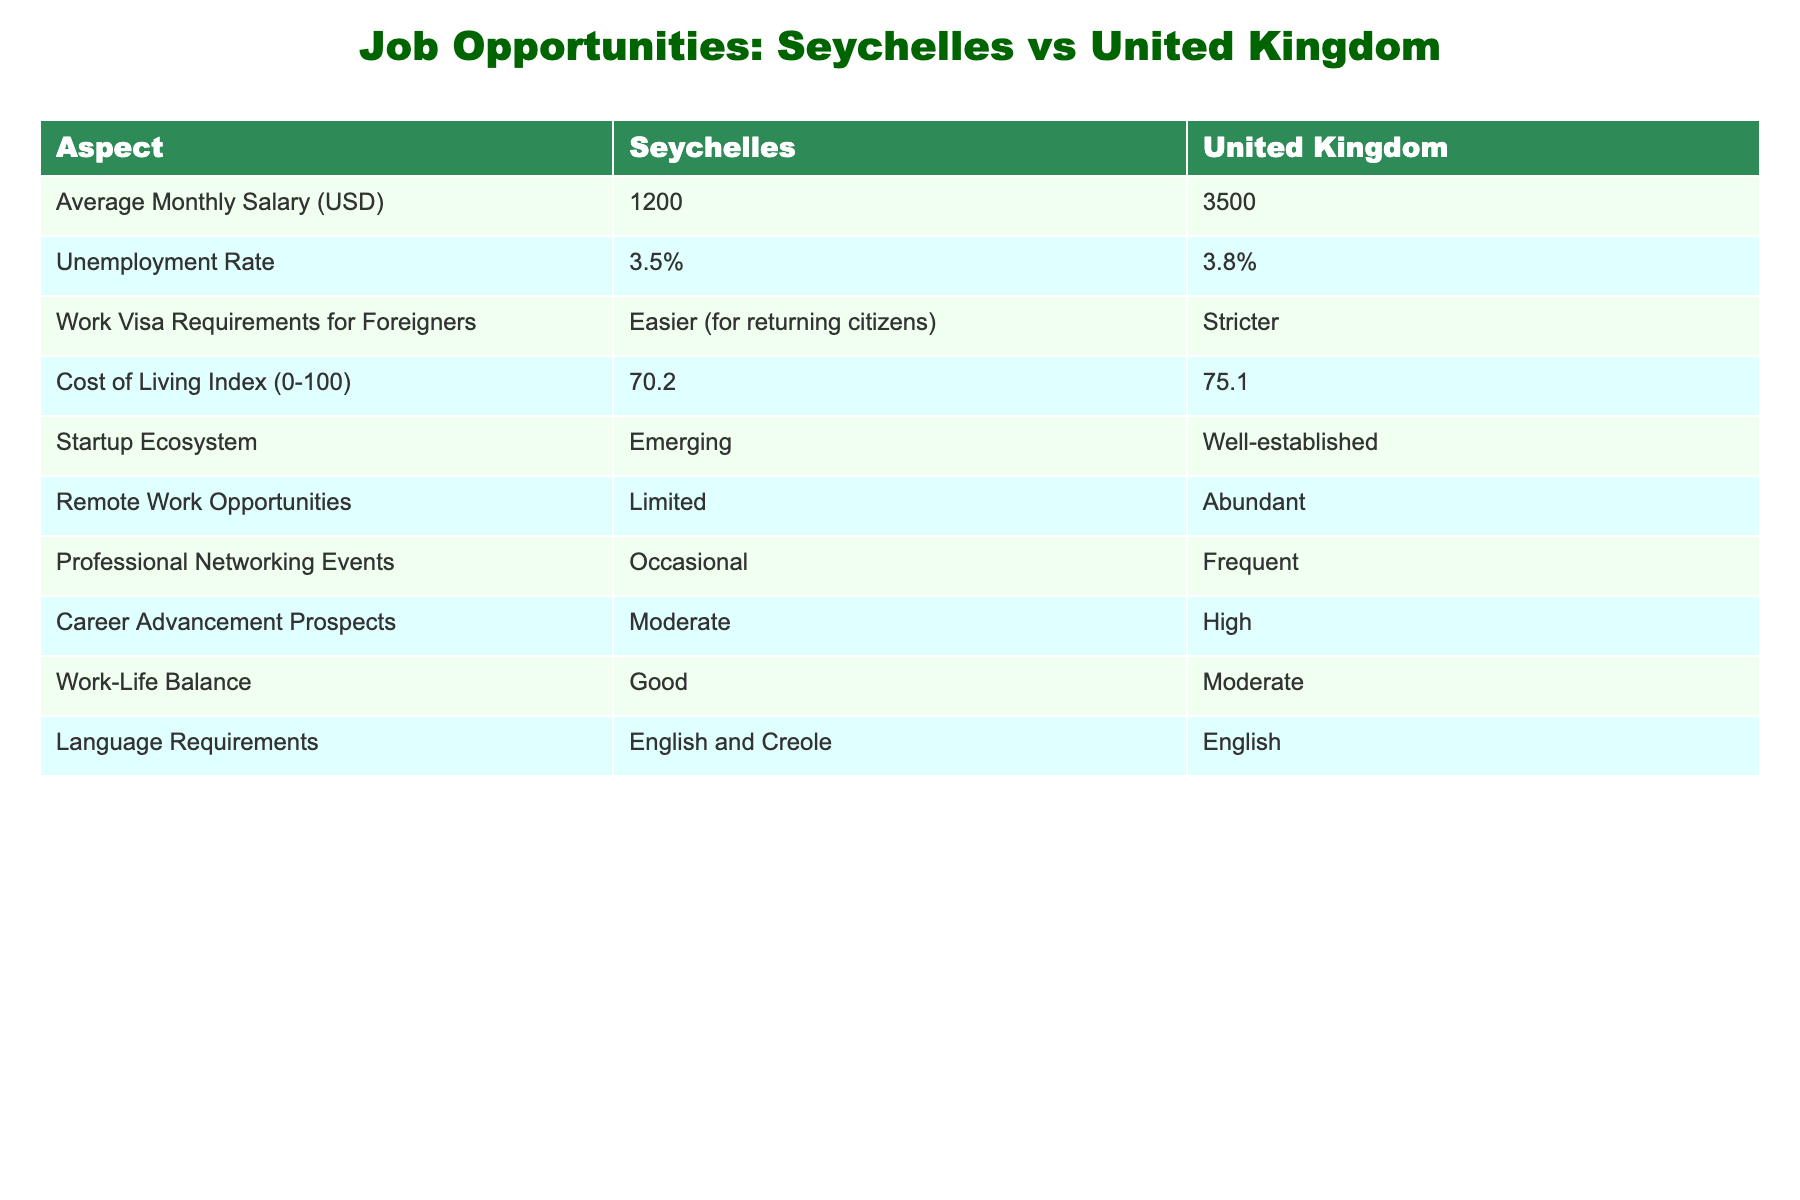What is the average monthly salary in Seychelles? The table shows that the average monthly salary in Seychelles is listed as 1200 USD.
Answer: 1200 USD Is the unemployment rate in the United Kingdom higher than in Seychelles? In the table, the unemployment rate for Seychelles is 3.5% and for the United Kingdom, it is 3.8%. Since 3.8% is greater than 3.5%, the unemployment rate in the United Kingdom is higher.
Answer: Yes What is the difference in average monthly salary between Seychelles and the United Kingdom? To find the difference, subtract Seychelles' average monthly salary from that of the United Kingdom: 3500 - 1200 = 2300 USD.
Answer: 2300 USD How does the cost of living index compare between Seychelles and the United Kingdom? The table shows a cost of living index of 70.2 for Seychelles and 75.1 for the United Kingdom. The United Kingdom has a higher index value than Seychelles, indicating a higher cost of living.
Answer: United Kingdom has a higher cost of living index Are remote work opportunities more abundant in Seychelles than in the United Kingdom? The table indicates that remote work opportunities in Seychelles are limited, while in the United Kingdom, they are abundant. This means that remote work opportunities are not more abundant in Seychelles.
Answer: No What can be inferred about the startup ecosystem in Seychelles compared to the United Kingdom? The table states that Seychelles has an emerging startup ecosystem, while the United Kingdom has a well-established one. This indicates that Seychelles is still developing its startup culture compared to the more mature environment in the United Kingdom.
Answer: Seychelles has an emerging startup ecosystem What language is required for employment in both Seychelles and the United Kingdom? Both the Seychelles and the United Kingdom list English as a language requirement; however, Seychelles also includes Creole. Therefore, English is essential in both places but Seychelles has an additional requirement.
Answer: English (and Creole for Seychelles) If you wanted to attend professional networking events, which country offers more frequent opportunities? According to the table, Seychelles has occasional professional networking events whereas the United Kingdom has frequent ones. Therefore, the United Kingdom offers more opportunities for attending such events.
Answer: United Kingdom offers more frequent opportunities 